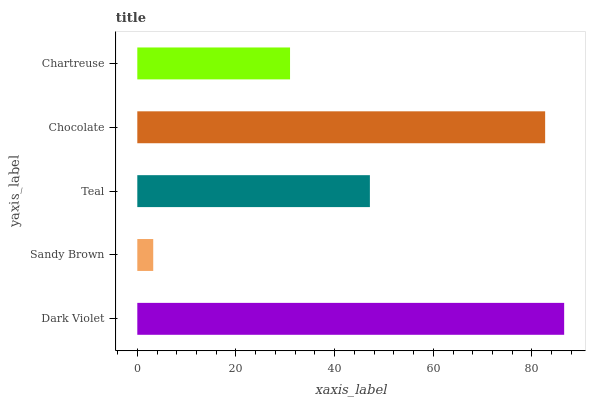Is Sandy Brown the minimum?
Answer yes or no. Yes. Is Dark Violet the maximum?
Answer yes or no. Yes. Is Teal the minimum?
Answer yes or no. No. Is Teal the maximum?
Answer yes or no. No. Is Teal greater than Sandy Brown?
Answer yes or no. Yes. Is Sandy Brown less than Teal?
Answer yes or no. Yes. Is Sandy Brown greater than Teal?
Answer yes or no. No. Is Teal less than Sandy Brown?
Answer yes or no. No. Is Teal the high median?
Answer yes or no. Yes. Is Teal the low median?
Answer yes or no. Yes. Is Chocolate the high median?
Answer yes or no. No. Is Sandy Brown the low median?
Answer yes or no. No. 